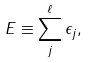<formula> <loc_0><loc_0><loc_500><loc_500>E \equiv \sum _ { j } ^ { \ell } \epsilon _ { j } ,</formula> 